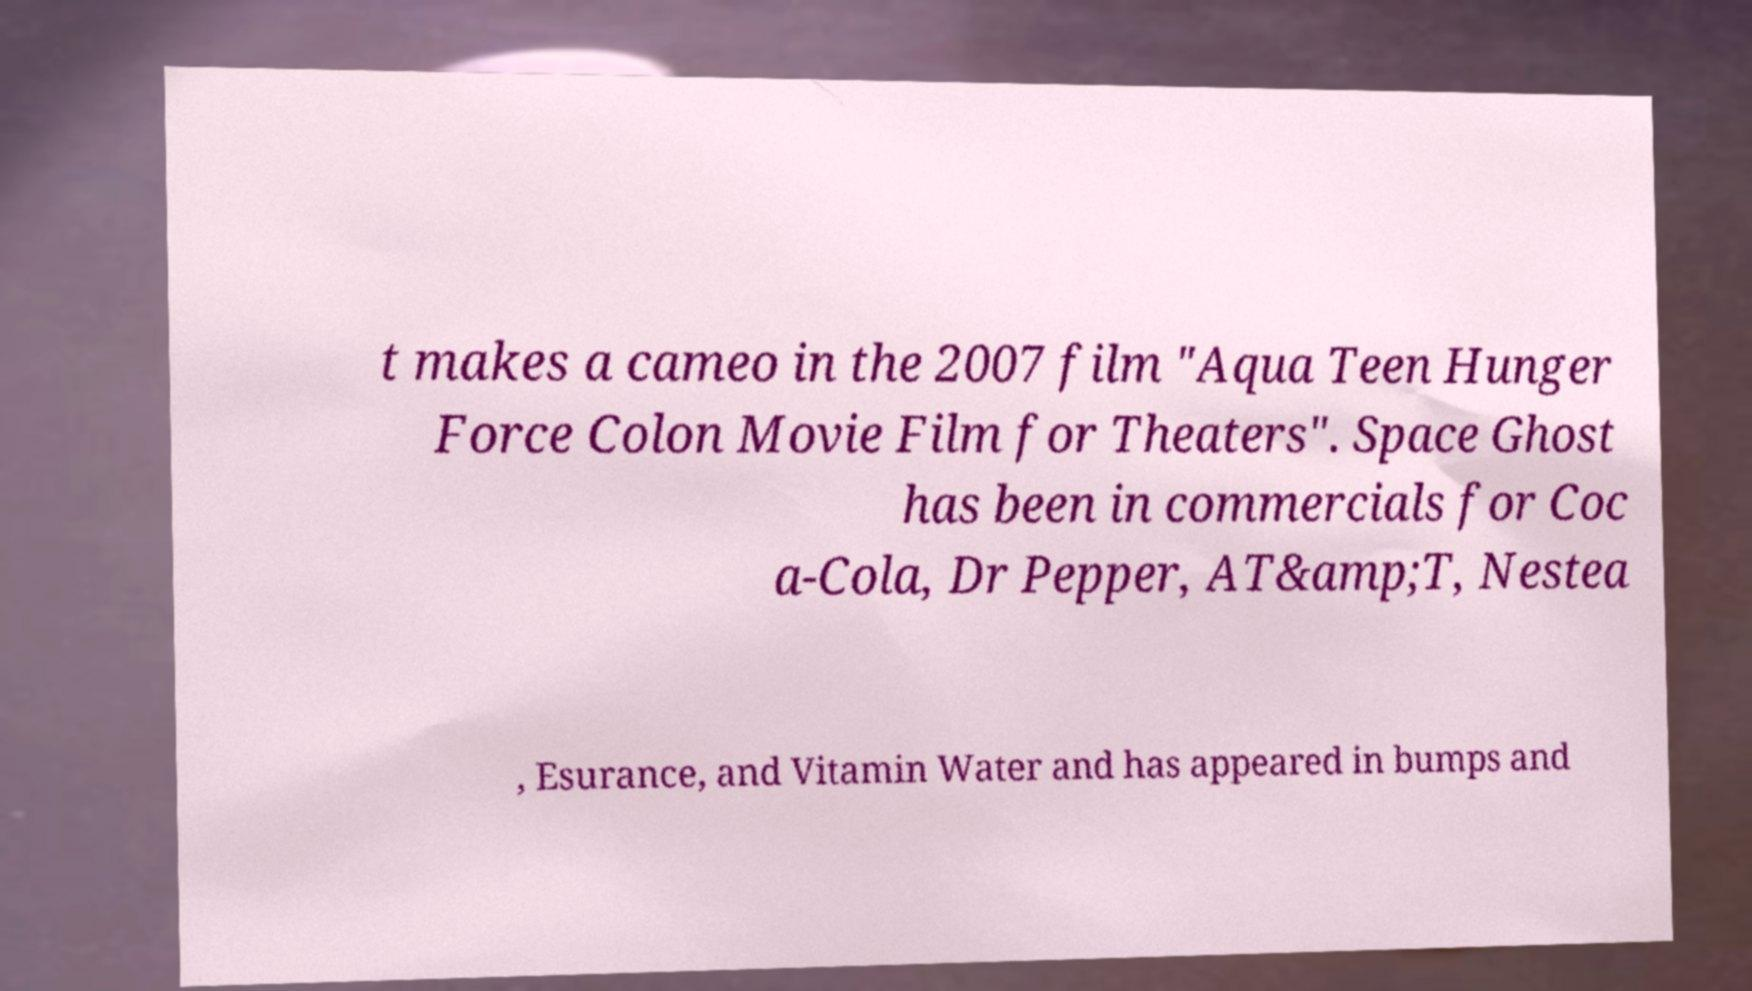Please identify and transcribe the text found in this image. t makes a cameo in the 2007 film "Aqua Teen Hunger Force Colon Movie Film for Theaters". Space Ghost has been in commercials for Coc a-Cola, Dr Pepper, AT&amp;T, Nestea , Esurance, and Vitamin Water and has appeared in bumps and 